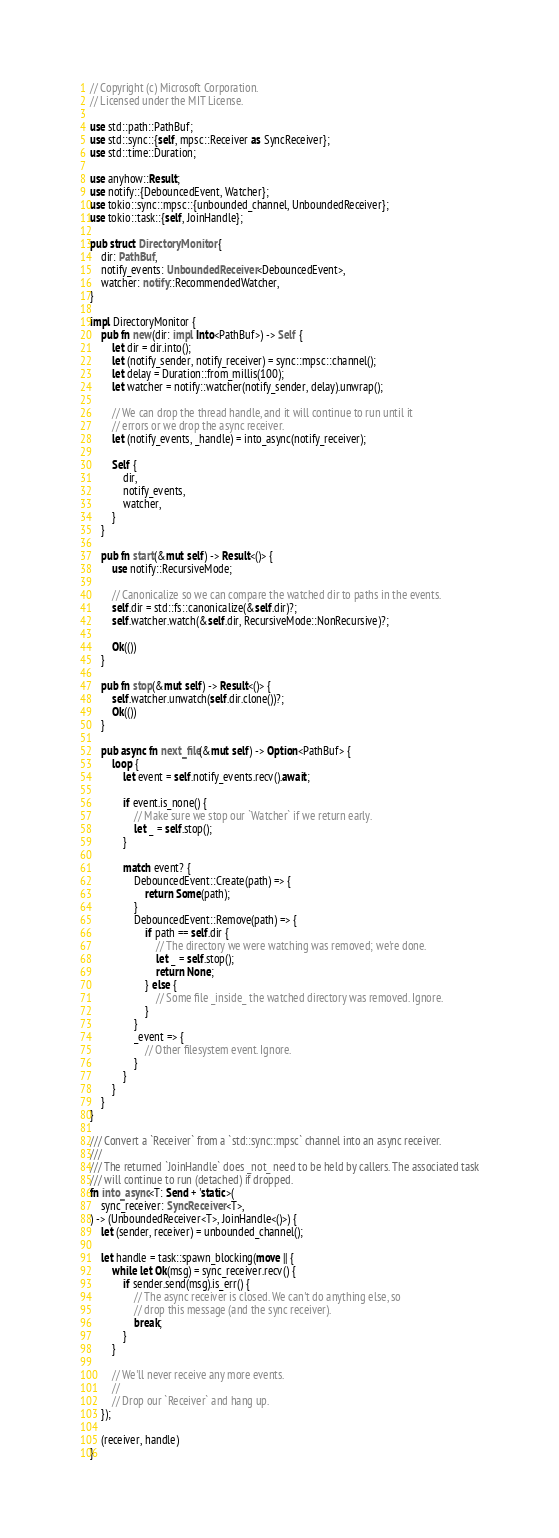Convert code to text. <code><loc_0><loc_0><loc_500><loc_500><_Rust_>// Copyright (c) Microsoft Corporation.
// Licensed under the MIT License.

use std::path::PathBuf;
use std::sync::{self, mpsc::Receiver as SyncReceiver};
use std::time::Duration;

use anyhow::Result;
use notify::{DebouncedEvent, Watcher};
use tokio::sync::mpsc::{unbounded_channel, UnboundedReceiver};
use tokio::task::{self, JoinHandle};

pub struct DirectoryMonitor {
    dir: PathBuf,
    notify_events: UnboundedReceiver<DebouncedEvent>,
    watcher: notify::RecommendedWatcher,
}

impl DirectoryMonitor {
    pub fn new(dir: impl Into<PathBuf>) -> Self {
        let dir = dir.into();
        let (notify_sender, notify_receiver) = sync::mpsc::channel();
        let delay = Duration::from_millis(100);
        let watcher = notify::watcher(notify_sender, delay).unwrap();

        // We can drop the thread handle, and it will continue to run until it
        // errors or we drop the async receiver.
        let (notify_events, _handle) = into_async(notify_receiver);

        Self {
            dir,
            notify_events,
            watcher,
        }
    }

    pub fn start(&mut self) -> Result<()> {
        use notify::RecursiveMode;

        // Canonicalize so we can compare the watched dir to paths in the events.
        self.dir = std::fs::canonicalize(&self.dir)?;
        self.watcher.watch(&self.dir, RecursiveMode::NonRecursive)?;

        Ok(())
    }

    pub fn stop(&mut self) -> Result<()> {
        self.watcher.unwatch(self.dir.clone())?;
        Ok(())
    }

    pub async fn next_file(&mut self) -> Option<PathBuf> {
        loop {
            let event = self.notify_events.recv().await;

            if event.is_none() {
                // Make sure we stop our `Watcher` if we return early.
                let _ = self.stop();
            }

            match event? {
                DebouncedEvent::Create(path) => {
                    return Some(path);
                }
                DebouncedEvent::Remove(path) => {
                    if path == self.dir {
                        // The directory we were watching was removed; we're done.
                        let _ = self.stop();
                        return None;
                    } else {
                        // Some file _inside_ the watched directory was removed. Ignore.
                    }
                }
                _event => {
                    // Other filesystem event. Ignore.
                }
            }
        }
    }
}

/// Convert a `Receiver` from a `std::sync::mpsc` channel into an async receiver.
///
/// The returned `JoinHandle` does _not_ need to be held by callers. The associated task
/// will continue to run (detached) if dropped.
fn into_async<T: Send + 'static>(
    sync_receiver: SyncReceiver<T>,
) -> (UnboundedReceiver<T>, JoinHandle<()>) {
    let (sender, receiver) = unbounded_channel();

    let handle = task::spawn_blocking(move || {
        while let Ok(msg) = sync_receiver.recv() {
            if sender.send(msg).is_err() {
                // The async receiver is closed. We can't do anything else, so
                // drop this message (and the sync receiver).
                break;
            }
        }

        // We'll never receive any more events.
        //
        // Drop our `Receiver` and hang up.
    });

    (receiver, handle)
}
</code> 